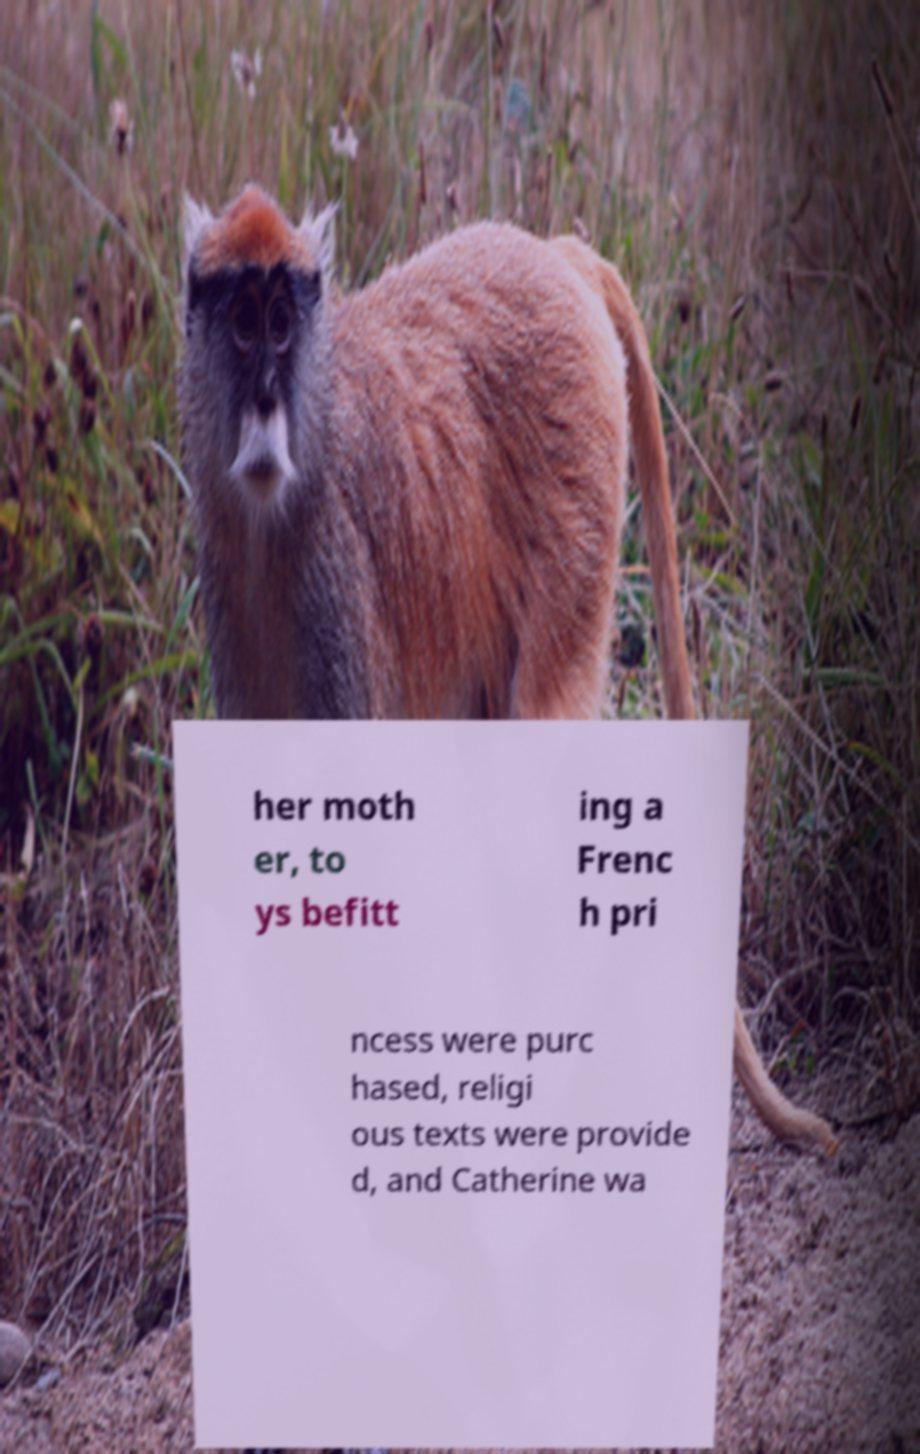What messages or text are displayed in this image? I need them in a readable, typed format. her moth er, to ys befitt ing a Frenc h pri ncess were purc hased, religi ous texts were provide d, and Catherine wa 